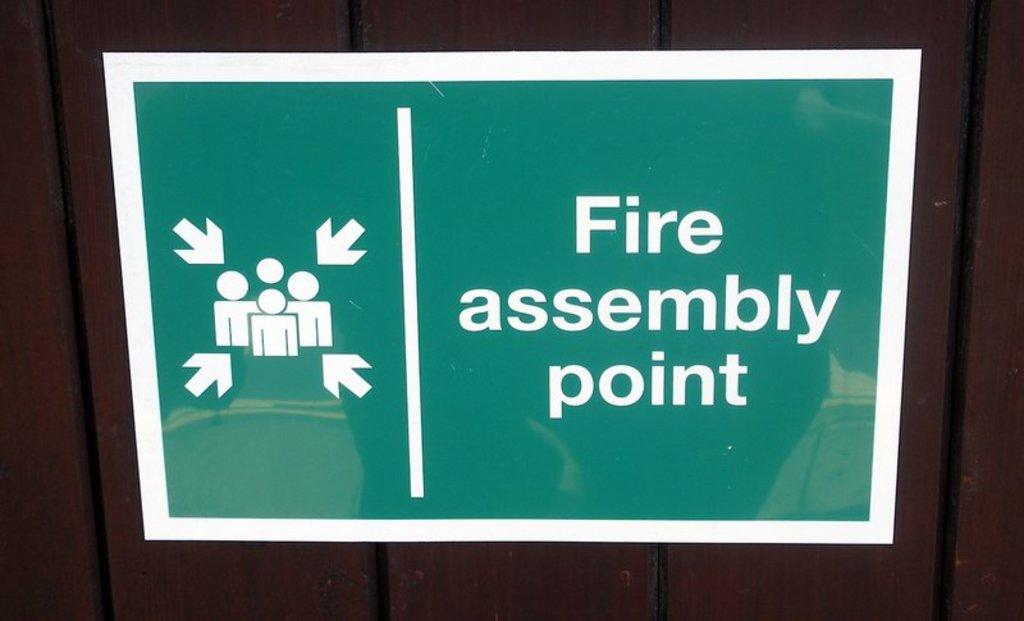<image>
Present a compact description of the photo's key features. A sign indicating where the fire assembly point is has arrows pointing at icons of people. 